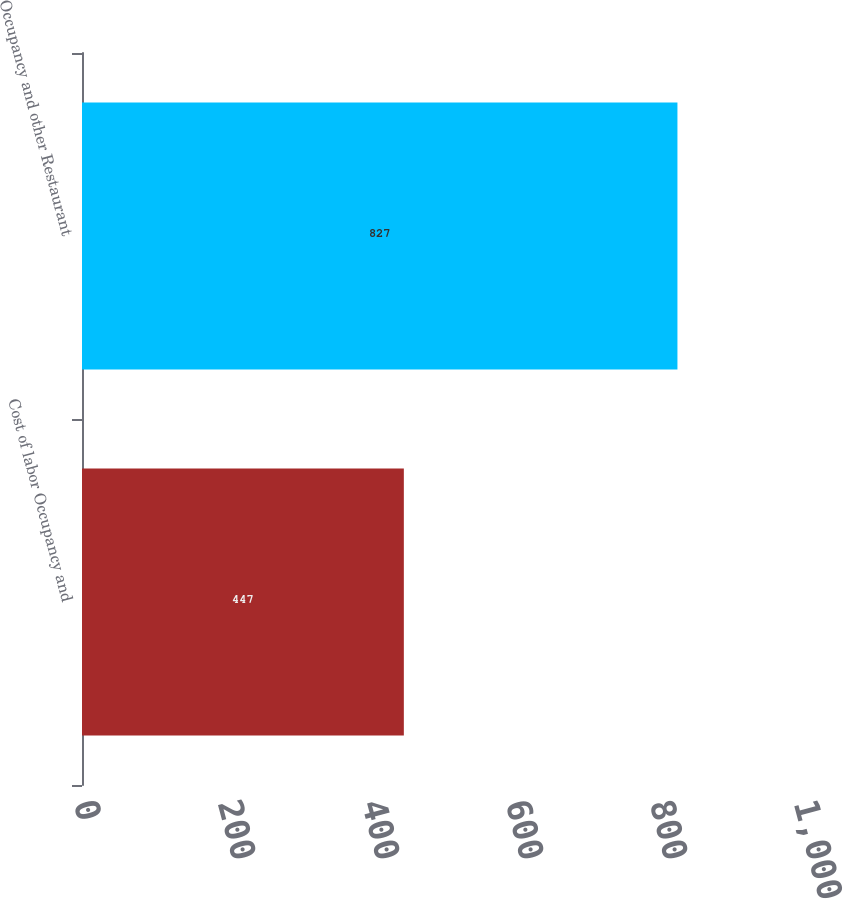Convert chart to OTSL. <chart><loc_0><loc_0><loc_500><loc_500><bar_chart><fcel>Cost of labor Occupancy and<fcel>Occupancy and other Restaurant<nl><fcel>447<fcel>827<nl></chart> 